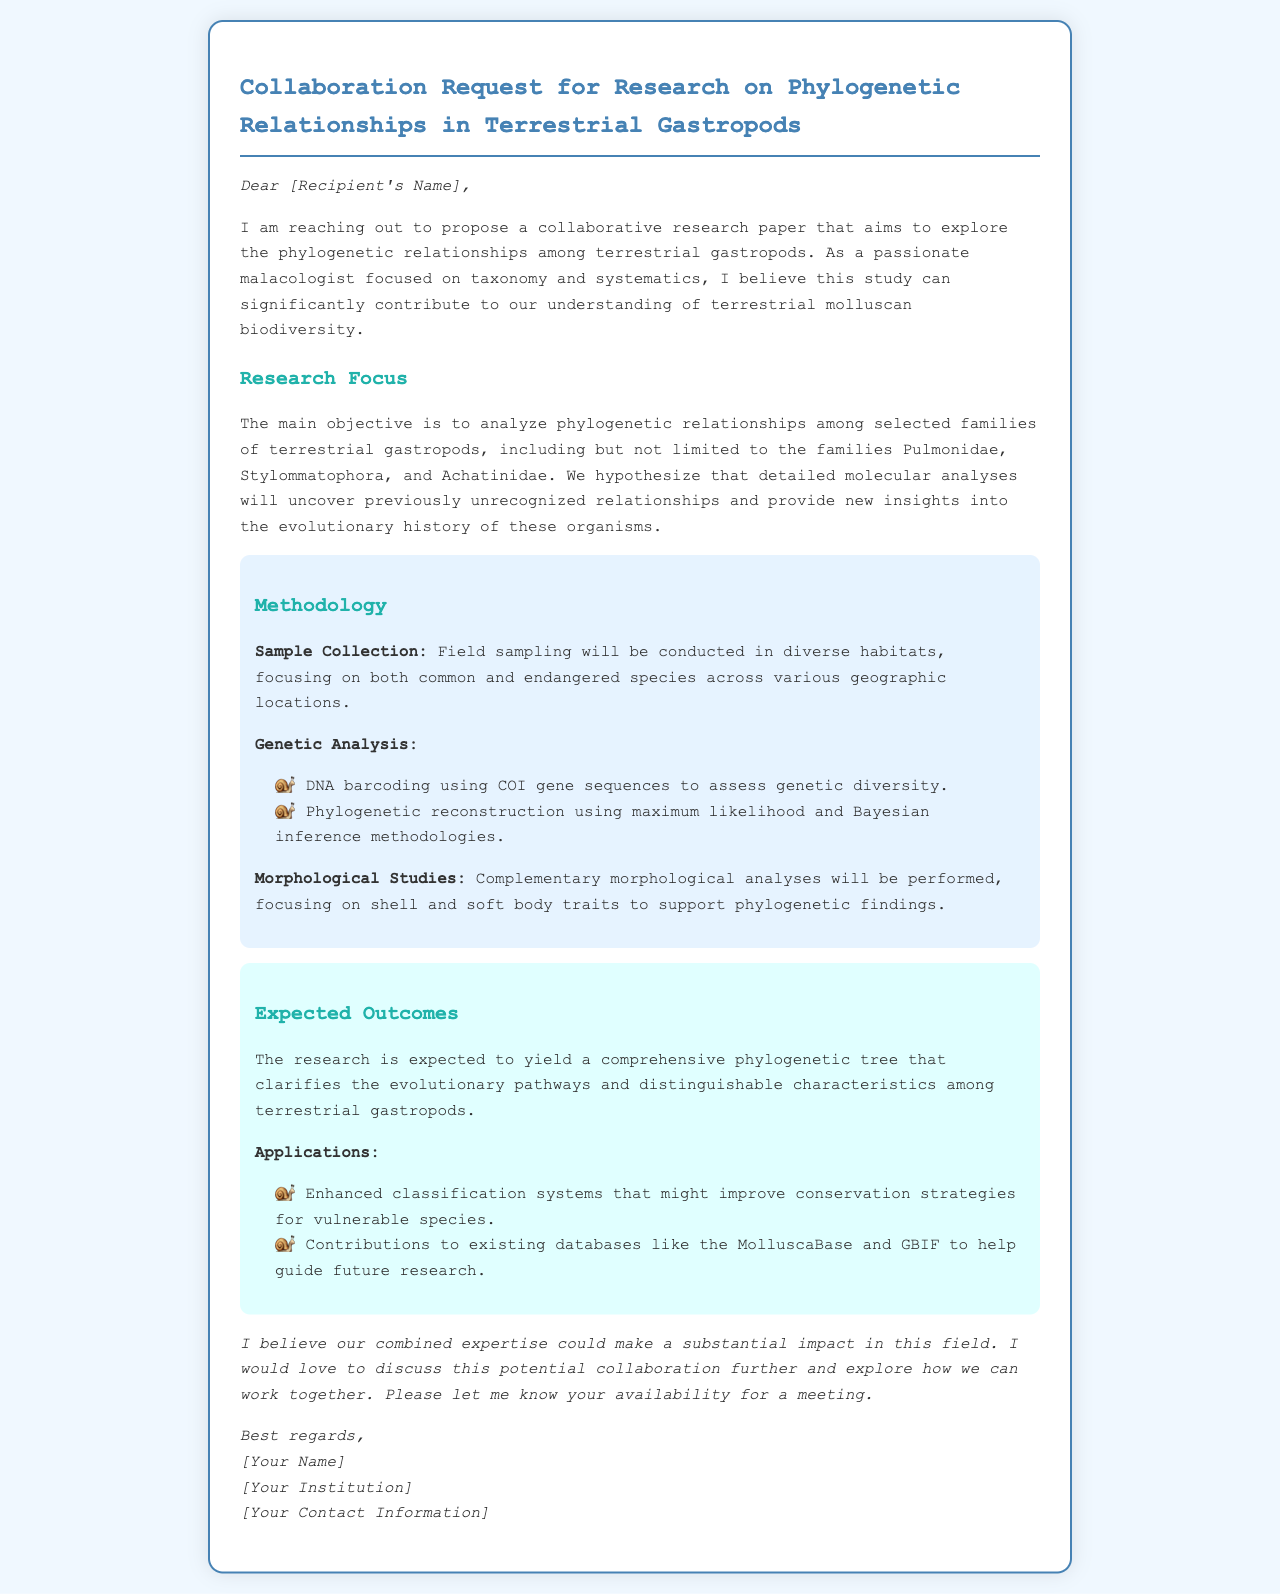What is the main objective of the research? The main objective is to analyze phylogenetic relationships among selected families of terrestrial gastropods.
Answer: Analyze phylogenetic relationships Who is the sender of the mail? The sender's name is mentioned in the signature at the end of the document.
Answer: [Your Name] What methodology will be used for genetic analysis? The document lists specific methodologies for genetic analysis, including techniques utilized in the study.
Answer: DNA barcoding What is one of the expected outcomes of the research? The document outlines the outcomes expected from the collaboration.
Answer: Comprehensive phylogenetic tree Which families of terrestrial gastropods will be analyzed? The document specifies families that are the focus of the research.
Answer: Pulmonidae, Stylommatophora, Achatinidae What type of analyses will complement genetic studies? The document states complementary analyses that will be performed alongside genetic studies.
Answer: Morphological studies What is the closing statement in the mail? The closing statement summarizes the intent to discuss collaboration further.
Answer: I would love to discuss this potential collaboration further What kind of sampling will be conducted? The document describes the nature of the sampling to be performed in the research.
Answer: Field sampling 